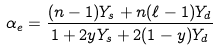<formula> <loc_0><loc_0><loc_500><loc_500>\alpha _ { e } = \frac { ( n - 1 ) Y _ { s } + n ( \ell - 1 ) Y _ { d } } { 1 + 2 y Y _ { s } + 2 ( 1 - y ) Y _ { d } }</formula> 